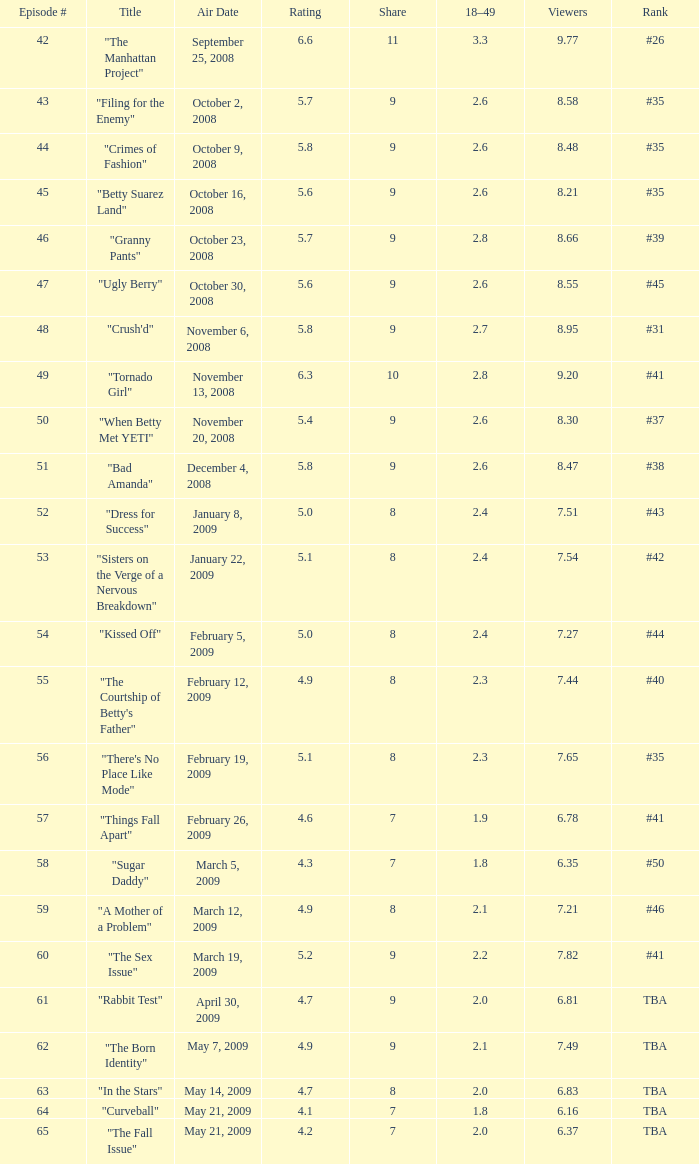What is the broadcast date with an 18-49 demographic larger than April 30, 2009, May 14, 2009, May 21, 2009. 